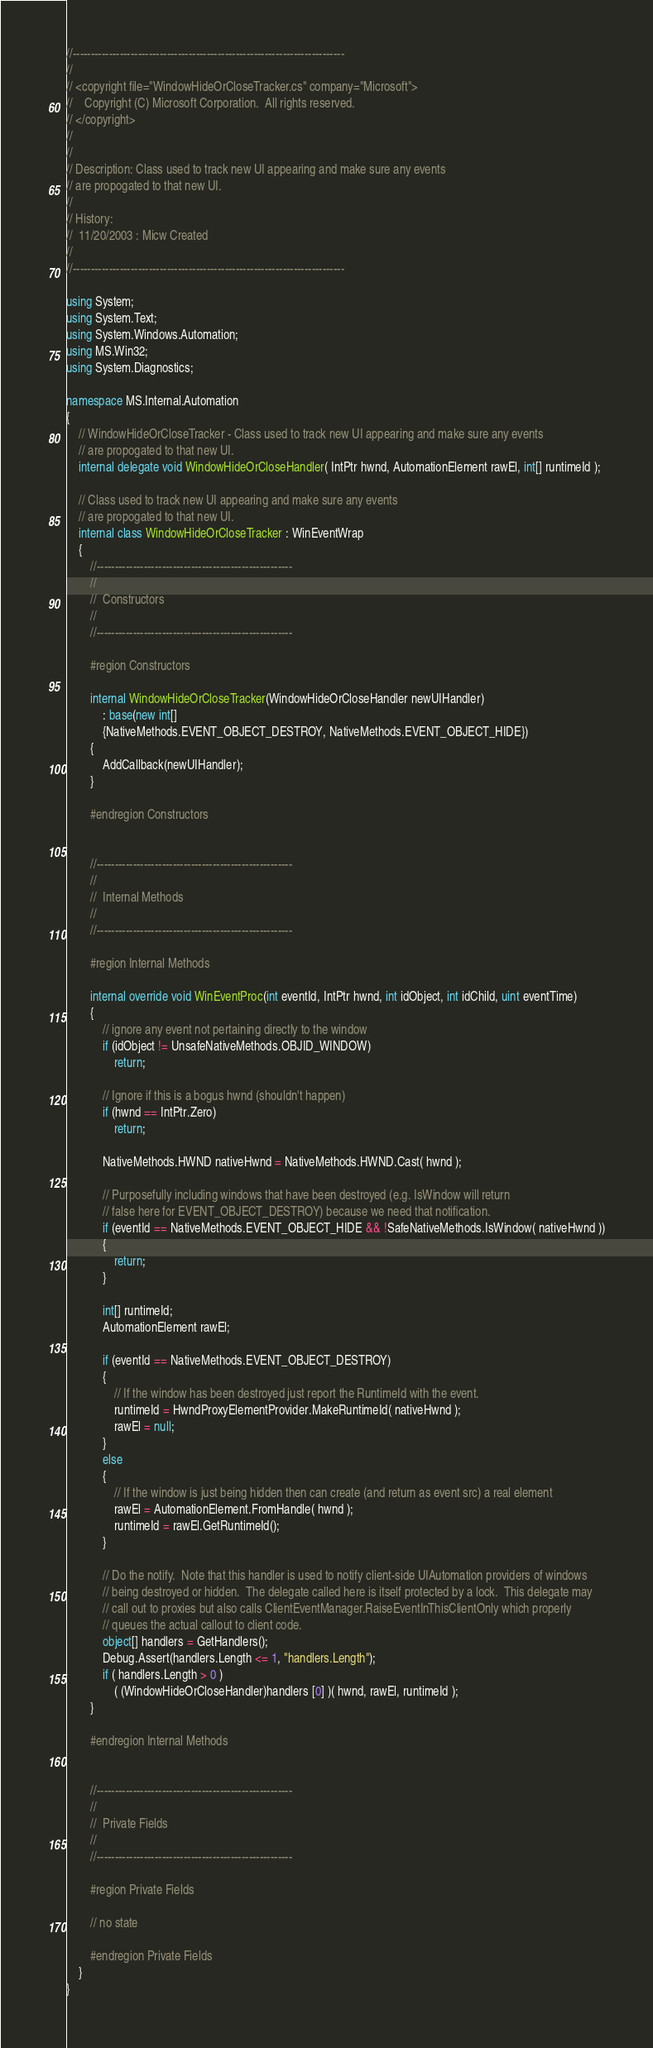Convert code to text. <code><loc_0><loc_0><loc_500><loc_500><_C#_>//---------------------------------------------------------------------------
//
// <copyright file="WindowHideOrCloseTracker.cs" company="Microsoft">
//    Copyright (C) Microsoft Corporation.  All rights reserved.
// </copyright>
// 
//
// Description: Class used to track new UI appearing and make sure any events
// are propogated to that new UI.
//
// History:  
//  11/20/2003 : Micw Created
//
//---------------------------------------------------------------------------

using System;
using System.Text;
using System.Windows.Automation;
using MS.Win32;
using System.Diagnostics;

namespace MS.Internal.Automation
{
    // WindowHideOrCloseTracker - Class used to track new UI appearing and make sure any events
    // are propogated to that new UI.
    internal delegate void WindowHideOrCloseHandler( IntPtr hwnd, AutomationElement rawEl, int[] runtimeId );

    // Class used to track new UI appearing and make sure any events
    // are propogated to that new UI.
    internal class WindowHideOrCloseTracker : WinEventWrap
    {
        //------------------------------------------------------
        //
        //  Constructors
        //
        //------------------------------------------------------
 
        #region Constructors

        internal WindowHideOrCloseTracker(WindowHideOrCloseHandler newUIHandler)
            : base(new int[]
            {NativeMethods.EVENT_OBJECT_DESTROY, NativeMethods.EVENT_OBJECT_HIDE}) 
        {
            AddCallback(newUIHandler);
        }

        #endregion Constructors


        //------------------------------------------------------
        //
        //  Internal Methods
        //
        //------------------------------------------------------
 
        #region Internal Methods

        internal override void WinEventProc(int eventId, IntPtr hwnd, int idObject, int idChild, uint eventTime)
        {
            // ignore any event not pertaining directly to the window
            if (idObject != UnsafeNativeMethods.OBJID_WINDOW)
                return;

            // Ignore if this is a bogus hwnd (shouldn't happen)
            if (hwnd == IntPtr.Zero)
                return;

            NativeMethods.HWND nativeHwnd = NativeMethods.HWND.Cast( hwnd );

            // Purposefully including windows that have been destroyed (e.g. IsWindow will return
            // false here for EVENT_OBJECT_DESTROY) because we need that notification.
            if (eventId == NativeMethods.EVENT_OBJECT_HIDE && !SafeNativeMethods.IsWindow( nativeHwnd ))
            {
                return;
            }

            int[] runtimeId;
            AutomationElement rawEl;

            if (eventId == NativeMethods.EVENT_OBJECT_DESTROY)
            {
                // If the window has been destroyed just report the RuntimeId with the event.
                runtimeId = HwndProxyElementProvider.MakeRuntimeId( nativeHwnd );
                rawEl = null;
            }
            else
            {
                // If the window is just being hidden then can create (and return as event src) a real element
                rawEl = AutomationElement.FromHandle( hwnd );
                runtimeId = rawEl.GetRuntimeId();
            }

            // Do the notify.  Note that this handler is used to notify client-side UIAutomation providers of windows
            // being destroyed or hidden.  The delegate called here is itself protected by a lock.  This delegate may
            // call out to proxies but also calls ClientEventManager.RaiseEventInThisClientOnly which properly
            // queues the actual callout to client code.
            object[] handlers = GetHandlers();
            Debug.Assert(handlers.Length <= 1, "handlers.Length");
            if ( handlers.Length > 0 )
                ( (WindowHideOrCloseHandler)handlers [0] )( hwnd, rawEl, runtimeId );
        }

        #endregion Internal Methods


        //------------------------------------------------------
        //
        //  Private Fields
        //
        //------------------------------------------------------
 
        #region Private Fields

        // no state

        #endregion Private Fields
    }
}
</code> 